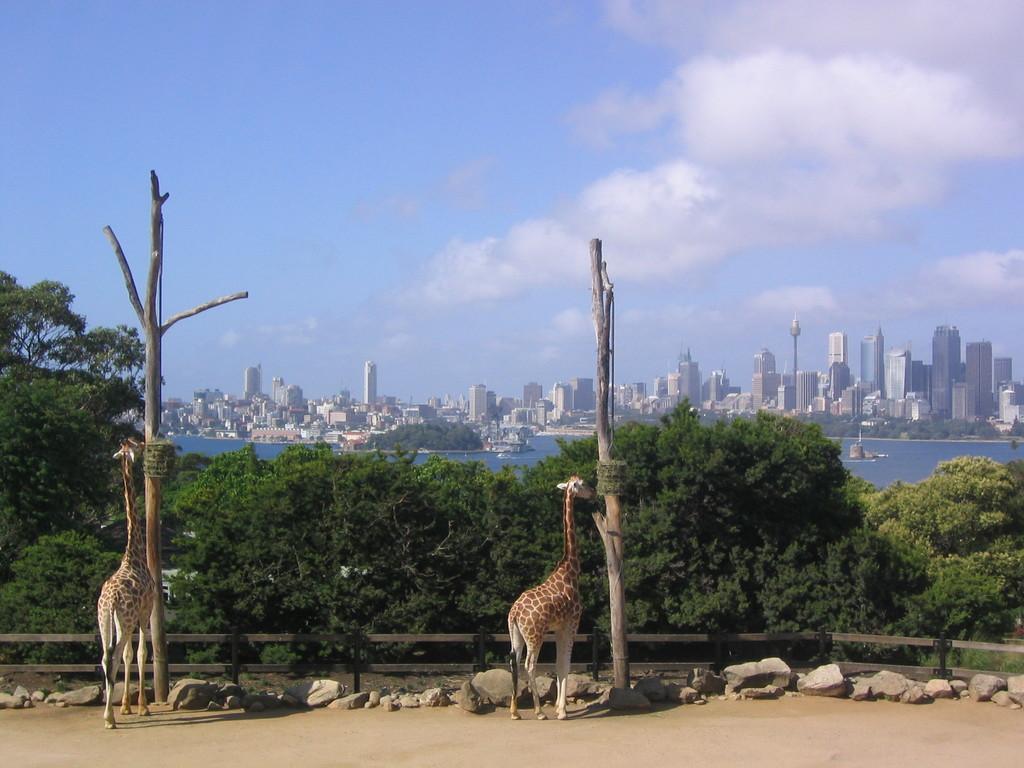In one or two sentences, can you explain what this image depicts? In this image, I can see two zebras eating food and at the back, I can see there are many trees, and in the middle I can see there are many building and water, and background is the sky. 